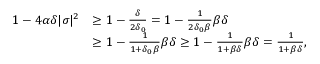Convert formula to latex. <formula><loc_0><loc_0><loc_500><loc_500>\begin{array} { r l } { 1 - 4 \alpha \delta | \sigma | ^ { 2 } } & { \geq 1 - \frac { \delta } { 2 \delta _ { 0 } } = 1 - \frac { 1 } { 2 \delta _ { 0 } \beta } \beta \delta } \\ & { \geq 1 - \frac { 1 } { 1 + \delta _ { 0 } \beta } \beta \delta \geq 1 - \frac { 1 } { 1 + \beta \delta } \beta \delta = \frac { 1 } { 1 + \beta \delta } , } \end{array}</formula> 